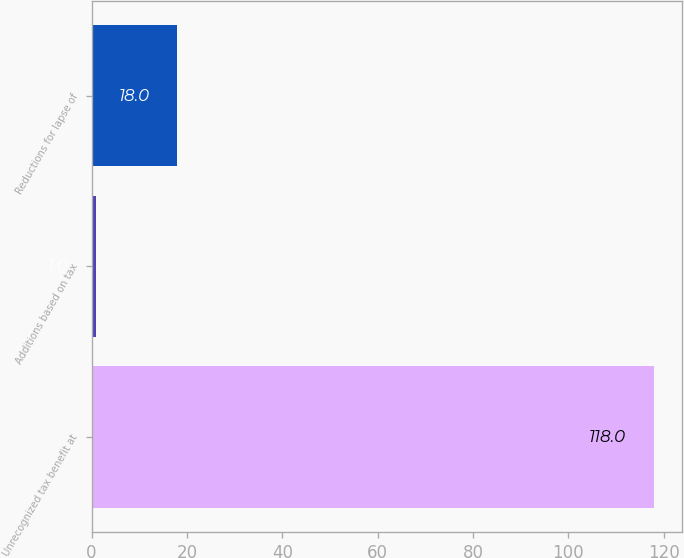Convert chart. <chart><loc_0><loc_0><loc_500><loc_500><bar_chart><fcel>Unrecognized tax benefit at<fcel>Additions based on tax<fcel>Reductions for lapse of<nl><fcel>118<fcel>1<fcel>18<nl></chart> 